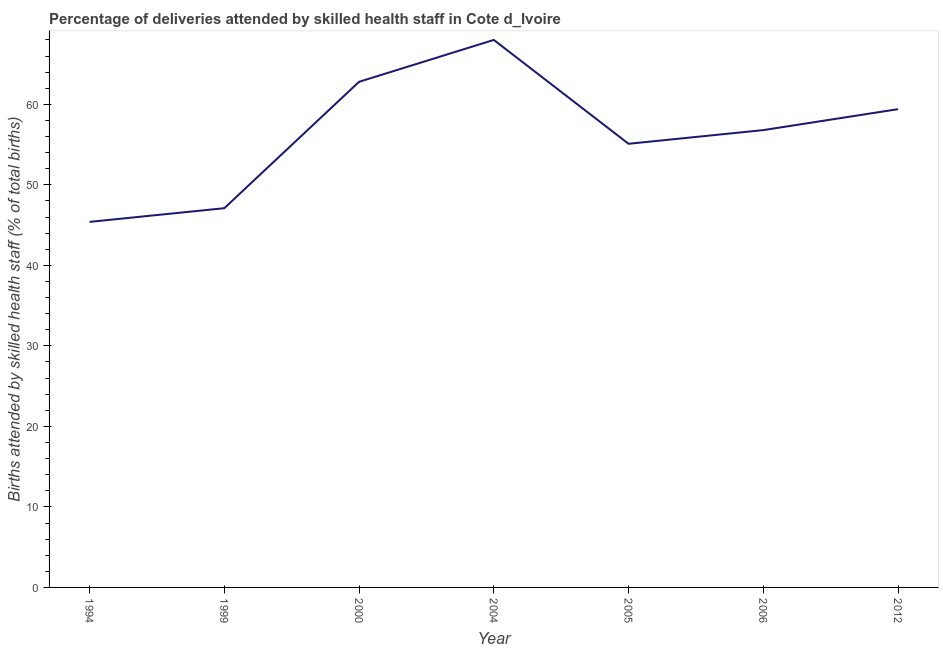What is the number of births attended by skilled health staff in 1999?
Your answer should be compact. 47.1. Across all years, what is the maximum number of births attended by skilled health staff?
Provide a succinct answer. 68. Across all years, what is the minimum number of births attended by skilled health staff?
Your answer should be compact. 45.4. In which year was the number of births attended by skilled health staff maximum?
Provide a succinct answer. 2004. What is the sum of the number of births attended by skilled health staff?
Keep it short and to the point. 394.6. What is the average number of births attended by skilled health staff per year?
Offer a terse response. 56.37. What is the median number of births attended by skilled health staff?
Your answer should be compact. 56.8. In how many years, is the number of births attended by skilled health staff greater than 10 %?
Give a very brief answer. 7. What is the ratio of the number of births attended by skilled health staff in 2006 to that in 2012?
Offer a very short reply. 0.96. Is the number of births attended by skilled health staff in 2004 less than that in 2005?
Keep it short and to the point. No. What is the difference between the highest and the second highest number of births attended by skilled health staff?
Your answer should be very brief. 5.2. What is the difference between the highest and the lowest number of births attended by skilled health staff?
Provide a succinct answer. 22.6. Does the number of births attended by skilled health staff monotonically increase over the years?
Make the answer very short. No. What is the difference between two consecutive major ticks on the Y-axis?
Ensure brevity in your answer.  10. Does the graph contain any zero values?
Your answer should be compact. No. What is the title of the graph?
Give a very brief answer. Percentage of deliveries attended by skilled health staff in Cote d_Ivoire. What is the label or title of the Y-axis?
Your answer should be very brief. Births attended by skilled health staff (% of total births). What is the Births attended by skilled health staff (% of total births) of 1994?
Give a very brief answer. 45.4. What is the Births attended by skilled health staff (% of total births) of 1999?
Make the answer very short. 47.1. What is the Births attended by skilled health staff (% of total births) of 2000?
Your answer should be compact. 62.8. What is the Births attended by skilled health staff (% of total births) in 2005?
Keep it short and to the point. 55.1. What is the Births attended by skilled health staff (% of total births) in 2006?
Offer a terse response. 56.8. What is the Births attended by skilled health staff (% of total births) of 2012?
Give a very brief answer. 59.4. What is the difference between the Births attended by skilled health staff (% of total births) in 1994 and 2000?
Give a very brief answer. -17.4. What is the difference between the Births attended by skilled health staff (% of total births) in 1994 and 2004?
Offer a very short reply. -22.6. What is the difference between the Births attended by skilled health staff (% of total births) in 1994 and 2012?
Give a very brief answer. -14. What is the difference between the Births attended by skilled health staff (% of total births) in 1999 and 2000?
Make the answer very short. -15.7. What is the difference between the Births attended by skilled health staff (% of total births) in 1999 and 2004?
Offer a terse response. -20.9. What is the difference between the Births attended by skilled health staff (% of total births) in 1999 and 2005?
Provide a succinct answer. -8. What is the difference between the Births attended by skilled health staff (% of total births) in 1999 and 2006?
Ensure brevity in your answer.  -9.7. What is the difference between the Births attended by skilled health staff (% of total births) in 1999 and 2012?
Your response must be concise. -12.3. What is the difference between the Births attended by skilled health staff (% of total births) in 2000 and 2004?
Ensure brevity in your answer.  -5.2. What is the difference between the Births attended by skilled health staff (% of total births) in 2000 and 2006?
Provide a short and direct response. 6. What is the difference between the Births attended by skilled health staff (% of total births) in 2000 and 2012?
Your answer should be compact. 3.4. What is the difference between the Births attended by skilled health staff (% of total births) in 2004 and 2006?
Your response must be concise. 11.2. What is the difference between the Births attended by skilled health staff (% of total births) in 2004 and 2012?
Provide a short and direct response. 8.6. What is the difference between the Births attended by skilled health staff (% of total births) in 2005 and 2006?
Your answer should be compact. -1.7. What is the difference between the Births attended by skilled health staff (% of total births) in 2006 and 2012?
Offer a terse response. -2.6. What is the ratio of the Births attended by skilled health staff (% of total births) in 1994 to that in 2000?
Provide a succinct answer. 0.72. What is the ratio of the Births attended by skilled health staff (% of total births) in 1994 to that in 2004?
Make the answer very short. 0.67. What is the ratio of the Births attended by skilled health staff (% of total births) in 1994 to that in 2005?
Give a very brief answer. 0.82. What is the ratio of the Births attended by skilled health staff (% of total births) in 1994 to that in 2006?
Your answer should be compact. 0.8. What is the ratio of the Births attended by skilled health staff (% of total births) in 1994 to that in 2012?
Your answer should be compact. 0.76. What is the ratio of the Births attended by skilled health staff (% of total births) in 1999 to that in 2000?
Offer a terse response. 0.75. What is the ratio of the Births attended by skilled health staff (% of total births) in 1999 to that in 2004?
Give a very brief answer. 0.69. What is the ratio of the Births attended by skilled health staff (% of total births) in 1999 to that in 2005?
Provide a short and direct response. 0.85. What is the ratio of the Births attended by skilled health staff (% of total births) in 1999 to that in 2006?
Ensure brevity in your answer.  0.83. What is the ratio of the Births attended by skilled health staff (% of total births) in 1999 to that in 2012?
Your response must be concise. 0.79. What is the ratio of the Births attended by skilled health staff (% of total births) in 2000 to that in 2004?
Your answer should be compact. 0.92. What is the ratio of the Births attended by skilled health staff (% of total births) in 2000 to that in 2005?
Your response must be concise. 1.14. What is the ratio of the Births attended by skilled health staff (% of total births) in 2000 to that in 2006?
Provide a succinct answer. 1.11. What is the ratio of the Births attended by skilled health staff (% of total births) in 2000 to that in 2012?
Give a very brief answer. 1.06. What is the ratio of the Births attended by skilled health staff (% of total births) in 2004 to that in 2005?
Give a very brief answer. 1.23. What is the ratio of the Births attended by skilled health staff (% of total births) in 2004 to that in 2006?
Provide a short and direct response. 1.2. What is the ratio of the Births attended by skilled health staff (% of total births) in 2004 to that in 2012?
Keep it short and to the point. 1.15. What is the ratio of the Births attended by skilled health staff (% of total births) in 2005 to that in 2012?
Your answer should be compact. 0.93. What is the ratio of the Births attended by skilled health staff (% of total births) in 2006 to that in 2012?
Give a very brief answer. 0.96. 